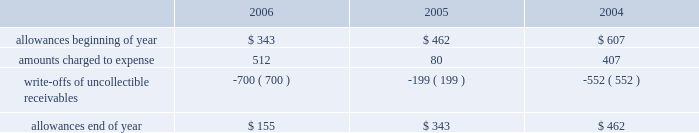Goodwill is reviewed annually during the fourth quarter for impairment .
In addition , the company performs an impairment analysis of other intangible assets based on the occurrence of other factors .
Such factors include , but are not limited to , significant changes in membership , state funding , medical contracts and provider networks and contracts .
An impairment loss is recognized if the carrying value of intangible assets exceeds the implied fair value .
Medical claims liabilities medical services costs include claims paid , claims reported but not yet paid , or inventory , estimates for claims incurred but not yet received , or ibnr , and estimates for the costs necessary to process unpaid claims .
The estimates of medical claims liabilities are developed using standard actuarial methods based upon historical data for payment patterns , cost trends , product mix , sea- sonality , utilization of healthcare services and other rele- vant factors including product changes .
These estimates are continually reviewed and adjustments , if necessary , are reflected in the period known .
Management did not change actuarial methods during the years presented .
Management believes the amount of medical claims payable is reasonable and adequate to cover the company 2019s liability for unpaid claims as of december 31 , 2006 ; however , actual claim payments may differ from established estimates .
Revenue recognition the company 2019s medicaid managed care segment gener- ates revenues primarily from premiums received from the states in which it operates health plans .
The company receives a fixed premium per member per month pursuant to our state contracts .
The company generally receives premium payments during the month it provides services and recognizes premium revenue during the period in which it is obligated to provide services to its members .
Some states enact premium taxes or similar assessments , collectively premium taxes , and these taxes are recorded as general and administrative expenses .
Some contracts allow for additional premium related to certain supplemen- tal services provided such as maternity deliveries .
Revenues are recorded based on membership and eligibility data provided by the states , which may be adjusted by the states for updates to this data .
These adjustments have been immaterial in relation to total revenue recorded and are reflected in the period known .
The company 2019s specialty services segment generates revenues under contracts with state programs , healthcare organizations and other commercial organizations , as well as from our own subsidiaries on market-based terms .
Revenues are recognized when the related services are provided or as ratably earned over the covered period of service .
Premium and services revenues collected in advance are recorded as unearned revenue .
For performance-based contracts the company does not recognize revenue subject to refund until data is sufficient to measure performance .
Premiums and service revenues due to the company are recorded as premium and related receivables and are recorded net of an allowance based on historical trends and management 2019s judgment on the collectibility of these accounts .
As the company generally receives payments during the month in which services are provided , the allowance is typically not significant in comparison to total revenues and does not have a material impact on the pres- entation of the financial condition or results of operations .
Activity in the allowance for uncollectible accounts for the years ended december 31 is summarized below: .
Significant customers centene receives the majority of its revenues under con- tracts or subcontracts with state medicaid managed care programs .
The contracts , which expire on various dates between june 30 , 2007 and december 31 , 2011 , are expected to be renewed .
Contracts with the states of georgia , indiana , kansas , texas and wisconsin each accounted for 15% ( 15 % ) , 15% ( 15 % ) , 10% ( 10 % ) , 17% ( 17 % ) and 16% ( 16 % ) , respectively , of the company 2019s revenues for the year ended december 31 , 2006 .
Reinsurance centene has purchased reinsurance from third parties to cover eligible healthcare services .
The current reinsurance program covers 90% ( 90 % ) of inpatient healthcare expenses in excess of annual deductibles of $ 300 to $ 500 per member , up to an annual maximum of $ 2000 .
Centene 2019s medicaid managed care subsidiaries are responsible for inpatient charges in excess of an average daily per diem .
In addition , bridgeway participates in a risk-sharing program as part of its contract with the state of arizona for the reimbursement of certain contract service costs beyond a monetary threshold .
Reinsurance recoveries were $ 3674 , $ 4014 , and $ 3730 , in 2006 , 2005 , and 2004 , respectively .
Reinsurance expenses were approximately $ 4842 , $ 4105 , and $ 6724 in 2006 , 2005 , and 2004 , respectively .
Reinsurance recoveries , net of expenses , are included in medical costs .
Other income ( expense ) other income ( expense ) consists principally of investment income and interest expense .
Investment income is derived from the company 2019s cash , cash equivalents , restricted deposits and investments. .
Without the ar write-offs in 2006 , what would the ending a/r allowance have been in millions? 
Computations: (155 - -700)
Answer: 855.0. Goodwill is reviewed annually during the fourth quarter for impairment .
In addition , the company performs an impairment analysis of other intangible assets based on the occurrence of other factors .
Such factors include , but are not limited to , significant changes in membership , state funding , medical contracts and provider networks and contracts .
An impairment loss is recognized if the carrying value of intangible assets exceeds the implied fair value .
Medical claims liabilities medical services costs include claims paid , claims reported but not yet paid , or inventory , estimates for claims incurred but not yet received , or ibnr , and estimates for the costs necessary to process unpaid claims .
The estimates of medical claims liabilities are developed using standard actuarial methods based upon historical data for payment patterns , cost trends , product mix , sea- sonality , utilization of healthcare services and other rele- vant factors including product changes .
These estimates are continually reviewed and adjustments , if necessary , are reflected in the period known .
Management did not change actuarial methods during the years presented .
Management believes the amount of medical claims payable is reasonable and adequate to cover the company 2019s liability for unpaid claims as of december 31 , 2006 ; however , actual claim payments may differ from established estimates .
Revenue recognition the company 2019s medicaid managed care segment gener- ates revenues primarily from premiums received from the states in which it operates health plans .
The company receives a fixed premium per member per month pursuant to our state contracts .
The company generally receives premium payments during the month it provides services and recognizes premium revenue during the period in which it is obligated to provide services to its members .
Some states enact premium taxes or similar assessments , collectively premium taxes , and these taxes are recorded as general and administrative expenses .
Some contracts allow for additional premium related to certain supplemen- tal services provided such as maternity deliveries .
Revenues are recorded based on membership and eligibility data provided by the states , which may be adjusted by the states for updates to this data .
These adjustments have been immaterial in relation to total revenue recorded and are reflected in the period known .
The company 2019s specialty services segment generates revenues under contracts with state programs , healthcare organizations and other commercial organizations , as well as from our own subsidiaries on market-based terms .
Revenues are recognized when the related services are provided or as ratably earned over the covered period of service .
Premium and services revenues collected in advance are recorded as unearned revenue .
For performance-based contracts the company does not recognize revenue subject to refund until data is sufficient to measure performance .
Premiums and service revenues due to the company are recorded as premium and related receivables and are recorded net of an allowance based on historical trends and management 2019s judgment on the collectibility of these accounts .
As the company generally receives payments during the month in which services are provided , the allowance is typically not significant in comparison to total revenues and does not have a material impact on the pres- entation of the financial condition or results of operations .
Activity in the allowance for uncollectible accounts for the years ended december 31 is summarized below: .
Significant customers centene receives the majority of its revenues under con- tracts or subcontracts with state medicaid managed care programs .
The contracts , which expire on various dates between june 30 , 2007 and december 31 , 2011 , are expected to be renewed .
Contracts with the states of georgia , indiana , kansas , texas and wisconsin each accounted for 15% ( 15 % ) , 15% ( 15 % ) , 10% ( 10 % ) , 17% ( 17 % ) and 16% ( 16 % ) , respectively , of the company 2019s revenues for the year ended december 31 , 2006 .
Reinsurance centene has purchased reinsurance from third parties to cover eligible healthcare services .
The current reinsurance program covers 90% ( 90 % ) of inpatient healthcare expenses in excess of annual deductibles of $ 300 to $ 500 per member , up to an annual maximum of $ 2000 .
Centene 2019s medicaid managed care subsidiaries are responsible for inpatient charges in excess of an average daily per diem .
In addition , bridgeway participates in a risk-sharing program as part of its contract with the state of arizona for the reimbursement of certain contract service costs beyond a monetary threshold .
Reinsurance recoveries were $ 3674 , $ 4014 , and $ 3730 , in 2006 , 2005 , and 2004 , respectively .
Reinsurance expenses were approximately $ 4842 , $ 4105 , and $ 6724 in 2006 , 2005 , and 2004 , respectively .
Reinsurance recoveries , net of expenses , are included in medical costs .
Other income ( expense ) other income ( expense ) consists principally of investment income and interest expense .
Investment income is derived from the company 2019s cash , cash equivalents , restricted deposits and investments. .
What was the percentage change in year end allowance for uncollectible accounts between 2005 and 2006? 
Computations: ((155 - 343) / 343)
Answer: -0.5481. Goodwill is reviewed annually during the fourth quarter for impairment .
In addition , the company performs an impairment analysis of other intangible assets based on the occurrence of other factors .
Such factors include , but are not limited to , significant changes in membership , state funding , medical contracts and provider networks and contracts .
An impairment loss is recognized if the carrying value of intangible assets exceeds the implied fair value .
Medical claims liabilities medical services costs include claims paid , claims reported but not yet paid , or inventory , estimates for claims incurred but not yet received , or ibnr , and estimates for the costs necessary to process unpaid claims .
The estimates of medical claims liabilities are developed using standard actuarial methods based upon historical data for payment patterns , cost trends , product mix , sea- sonality , utilization of healthcare services and other rele- vant factors including product changes .
These estimates are continually reviewed and adjustments , if necessary , are reflected in the period known .
Management did not change actuarial methods during the years presented .
Management believes the amount of medical claims payable is reasonable and adequate to cover the company 2019s liability for unpaid claims as of december 31 , 2006 ; however , actual claim payments may differ from established estimates .
Revenue recognition the company 2019s medicaid managed care segment gener- ates revenues primarily from premiums received from the states in which it operates health plans .
The company receives a fixed premium per member per month pursuant to our state contracts .
The company generally receives premium payments during the month it provides services and recognizes premium revenue during the period in which it is obligated to provide services to its members .
Some states enact premium taxes or similar assessments , collectively premium taxes , and these taxes are recorded as general and administrative expenses .
Some contracts allow for additional premium related to certain supplemen- tal services provided such as maternity deliveries .
Revenues are recorded based on membership and eligibility data provided by the states , which may be adjusted by the states for updates to this data .
These adjustments have been immaterial in relation to total revenue recorded and are reflected in the period known .
The company 2019s specialty services segment generates revenues under contracts with state programs , healthcare organizations and other commercial organizations , as well as from our own subsidiaries on market-based terms .
Revenues are recognized when the related services are provided or as ratably earned over the covered period of service .
Premium and services revenues collected in advance are recorded as unearned revenue .
For performance-based contracts the company does not recognize revenue subject to refund until data is sufficient to measure performance .
Premiums and service revenues due to the company are recorded as premium and related receivables and are recorded net of an allowance based on historical trends and management 2019s judgment on the collectibility of these accounts .
As the company generally receives payments during the month in which services are provided , the allowance is typically not significant in comparison to total revenues and does not have a material impact on the pres- entation of the financial condition or results of operations .
Activity in the allowance for uncollectible accounts for the years ended december 31 is summarized below: .
Significant customers centene receives the majority of its revenues under con- tracts or subcontracts with state medicaid managed care programs .
The contracts , which expire on various dates between june 30 , 2007 and december 31 , 2011 , are expected to be renewed .
Contracts with the states of georgia , indiana , kansas , texas and wisconsin each accounted for 15% ( 15 % ) , 15% ( 15 % ) , 10% ( 10 % ) , 17% ( 17 % ) and 16% ( 16 % ) , respectively , of the company 2019s revenues for the year ended december 31 , 2006 .
Reinsurance centene has purchased reinsurance from third parties to cover eligible healthcare services .
The current reinsurance program covers 90% ( 90 % ) of inpatient healthcare expenses in excess of annual deductibles of $ 300 to $ 500 per member , up to an annual maximum of $ 2000 .
Centene 2019s medicaid managed care subsidiaries are responsible for inpatient charges in excess of an average daily per diem .
In addition , bridgeway participates in a risk-sharing program as part of its contract with the state of arizona for the reimbursement of certain contract service costs beyond a monetary threshold .
Reinsurance recoveries were $ 3674 , $ 4014 , and $ 3730 , in 2006 , 2005 , and 2004 , respectively .
Reinsurance expenses were approximately $ 4842 , $ 4105 , and $ 6724 in 2006 , 2005 , and 2004 , respectively .
Reinsurance recoveries , net of expenses , are included in medical costs .
Other income ( expense ) other income ( expense ) consists principally of investment income and interest expense .
Investment income is derived from the company 2019s cash , cash equivalents , restricted deposits and investments. .
If the company lost its contracts with the states of georgia and indiana , what would be the % (  % ) decline in revenue for the year ended december 31 , 2006? 
Computations: (15 + 15)
Answer: 30.0. 